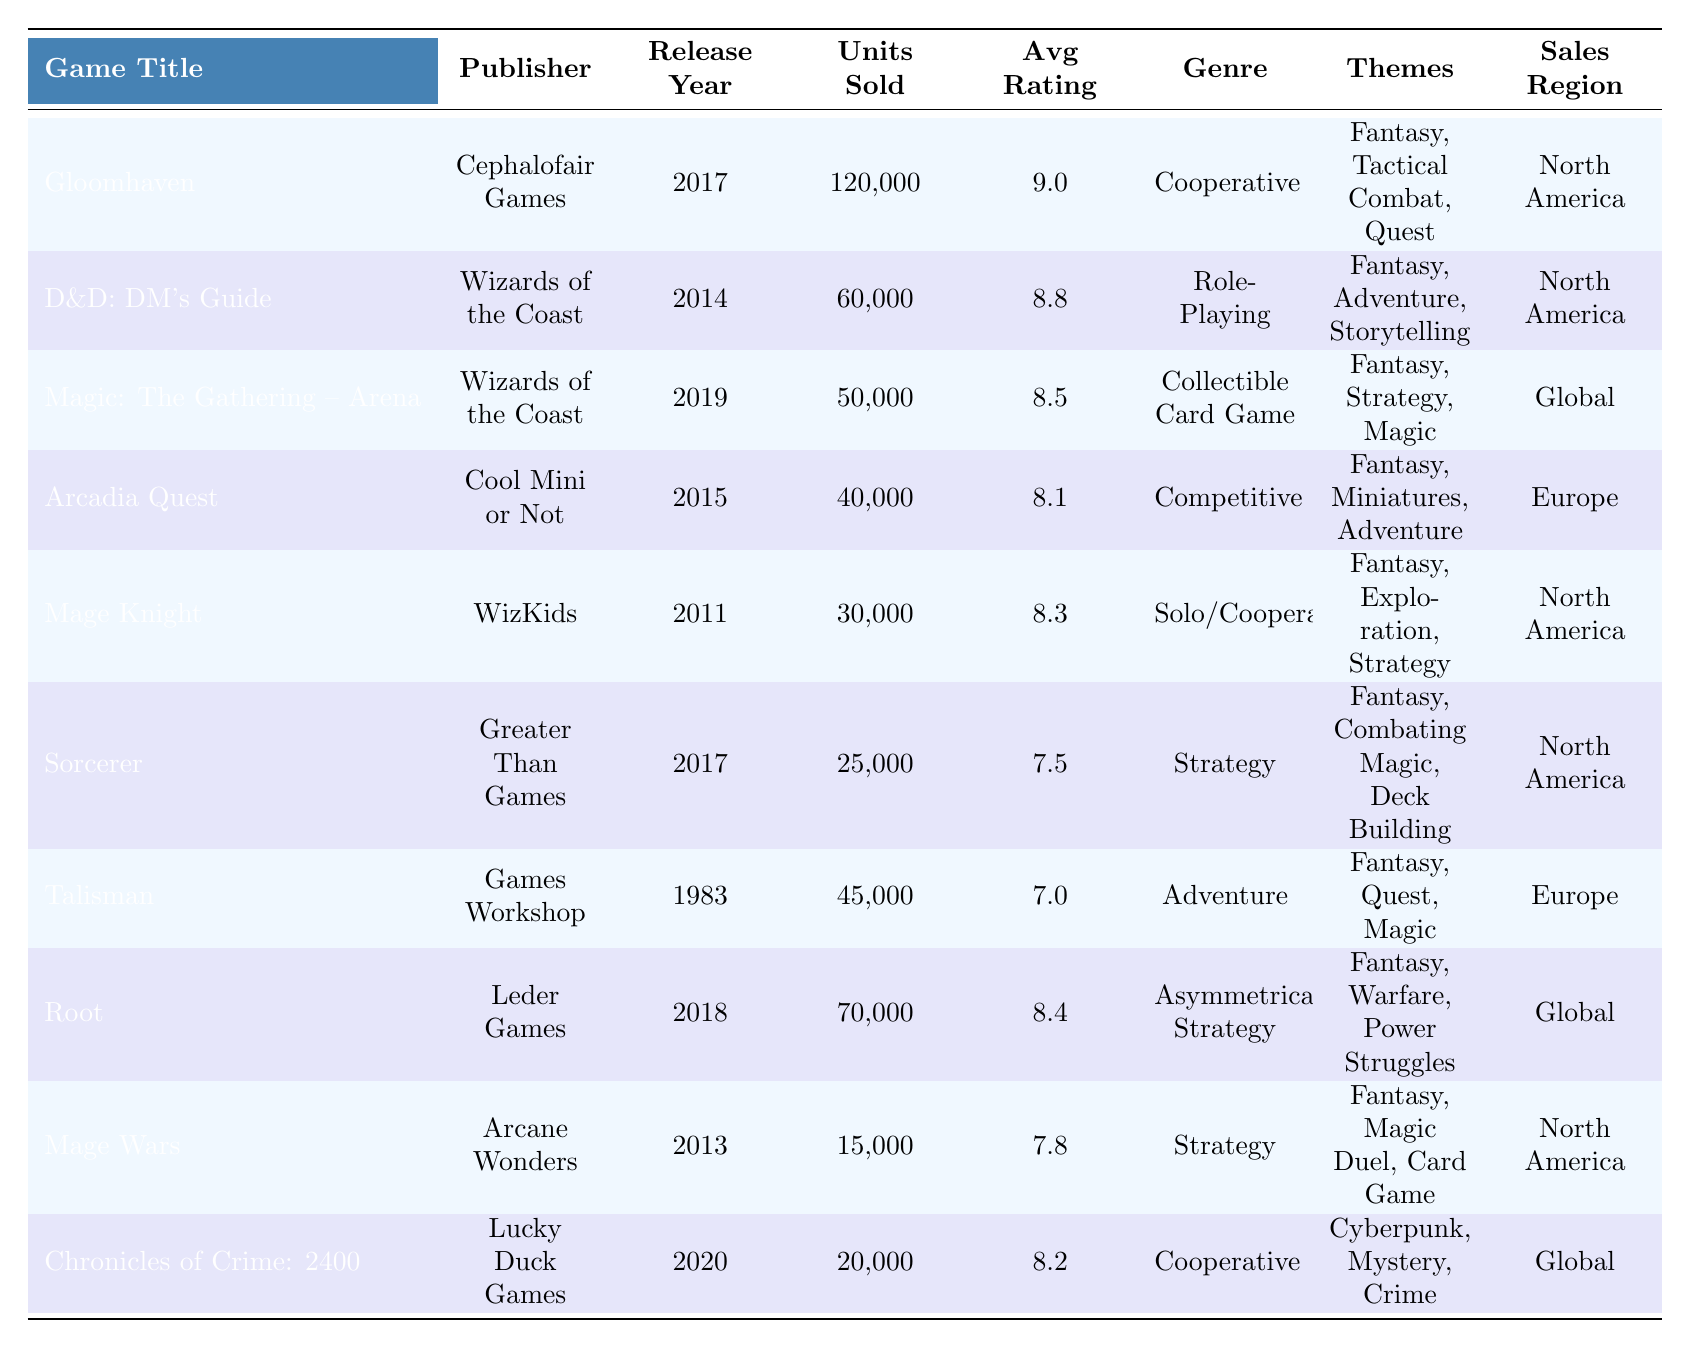What is the highest-selling magic-themed board game in the table? The table shows that "Gloomhaven" has the highest units sold at 120,000.
Answer: Gloomhaven Which game was published by Wizards of the Coast? Both "Dungeons & Dragons: Dungeon Master's Guide" and "Magic: The Gathering – Arena" were published by Wizards of the Coast.
Answer: Dungeons & Dragons: Dungeon Master's Guide and Magic: The Gathering – Arena How many units did "Talisman" sell? The table lists the units sold for "Talisman" as 45,000.
Answer: 45,000 What is the average rating of games sold in Europe? The games listed in Europe are "Arcadia Quest" (8.1), "Talisman" (7.0), and "Sorcerer" (7.5). Summing the ratings gives (8.1 + 7.0 + 7.5) = 22.6, and dividing by 3 gives an average of 22.6 / 3 = 7.53.
Answer: 7.53 Did any game have an average rating of 9.0 or higher? Yes, "Gloomhaven" has an average rating of 9.0, which meets the criteria.
Answer: Yes What is the total number of units sold for the games listed under the "North America" sales region? Adding the units sold for North America: 120,000 (Gloomhaven) + 60,000 (D&D: DM's Guide) + 50,000 (Magic: The Gathering - Arena) + 30,000 (Mage Knight) + 25,000 (Sorcerer) + 15,000 (Mage Wars) = 300,000.
Answer: 300,000 Which publisher released the least number of units sold? "Mage Wars" by Arcane Wonders sold the least with only 15,000 units.
Answer: Arcane Wonders Were there any games that had "Adventure" as a theme? Yes, both "Dungeons & Dragons: Dungeon Master's Guide" and "Talisman" have "Adventure" as part of their themes.
Answer: Yes How many themes are associated with "Root"? The game "Root" is associated with three themes: Fantasy, Warfare, and Power Struggles.
Answer: 3 Which game had the highest average rating among the games released in or after 2015? The games released from 2015 onward are "Gloomhaven" (9.0), "D&D: DM's Guide" (8.8), "Magic: The Gathering – Arena" (8.5), "Arcadia Quest" (8.1), "Root" (8.4), and "Sorcerer" (7.5). The highest average rating among these is 9.0 by "Gloomhaven".
Answer: Gloomhaven Is there a game that has the theme "Magic Duel"? Yes, "Mage Wars" has the theme "Magic Duel".
Answer: Yes 